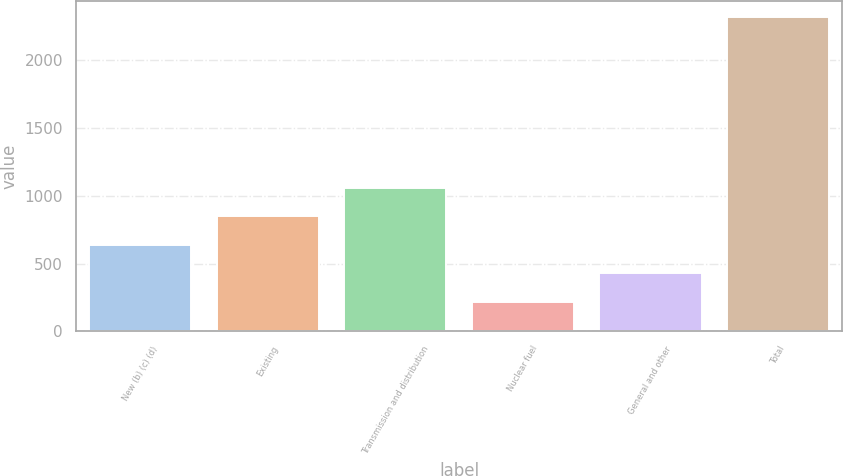Convert chart. <chart><loc_0><loc_0><loc_500><loc_500><bar_chart><fcel>New (b) (c) (d)<fcel>Existing<fcel>Transmission and distribution<fcel>Nuclear fuel<fcel>General and other<fcel>Total<nl><fcel>640<fcel>850<fcel>1060<fcel>220<fcel>430<fcel>2320<nl></chart> 